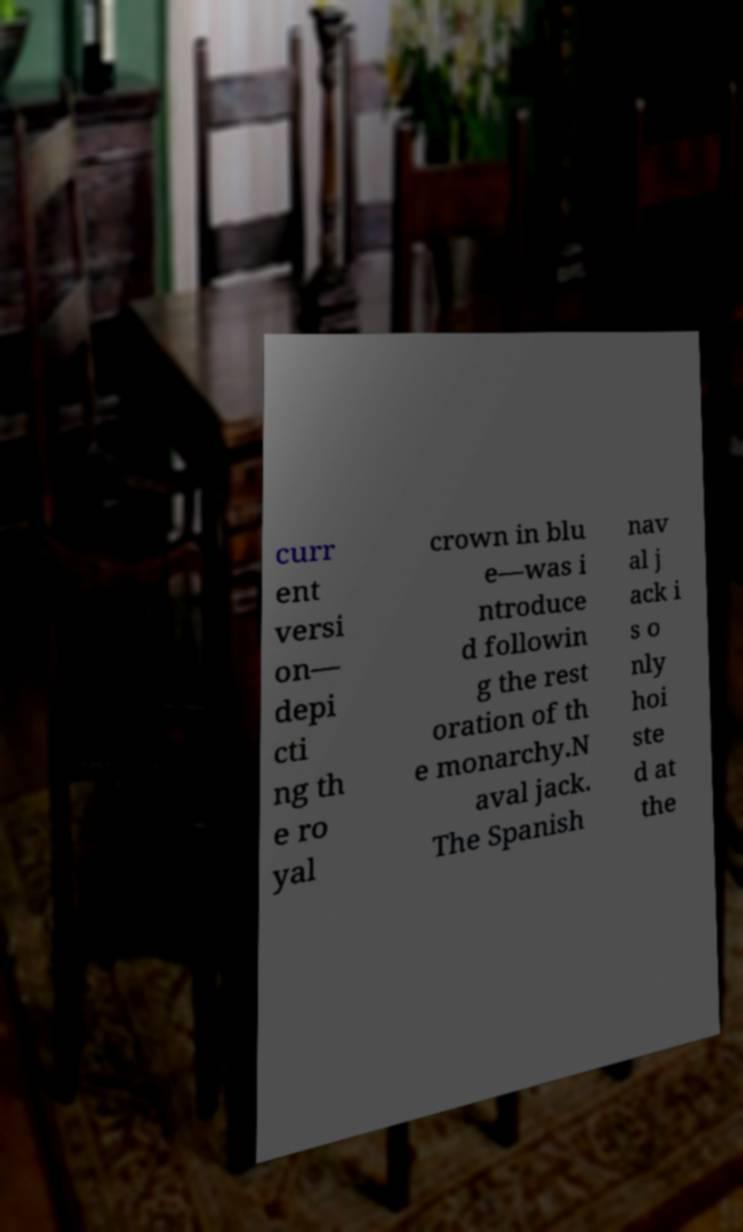Can you accurately transcribe the text from the provided image for me? curr ent versi on— depi cti ng th e ro yal crown in blu e—was i ntroduce d followin g the rest oration of th e monarchy.N aval jack. The Spanish nav al j ack i s o nly hoi ste d at the 